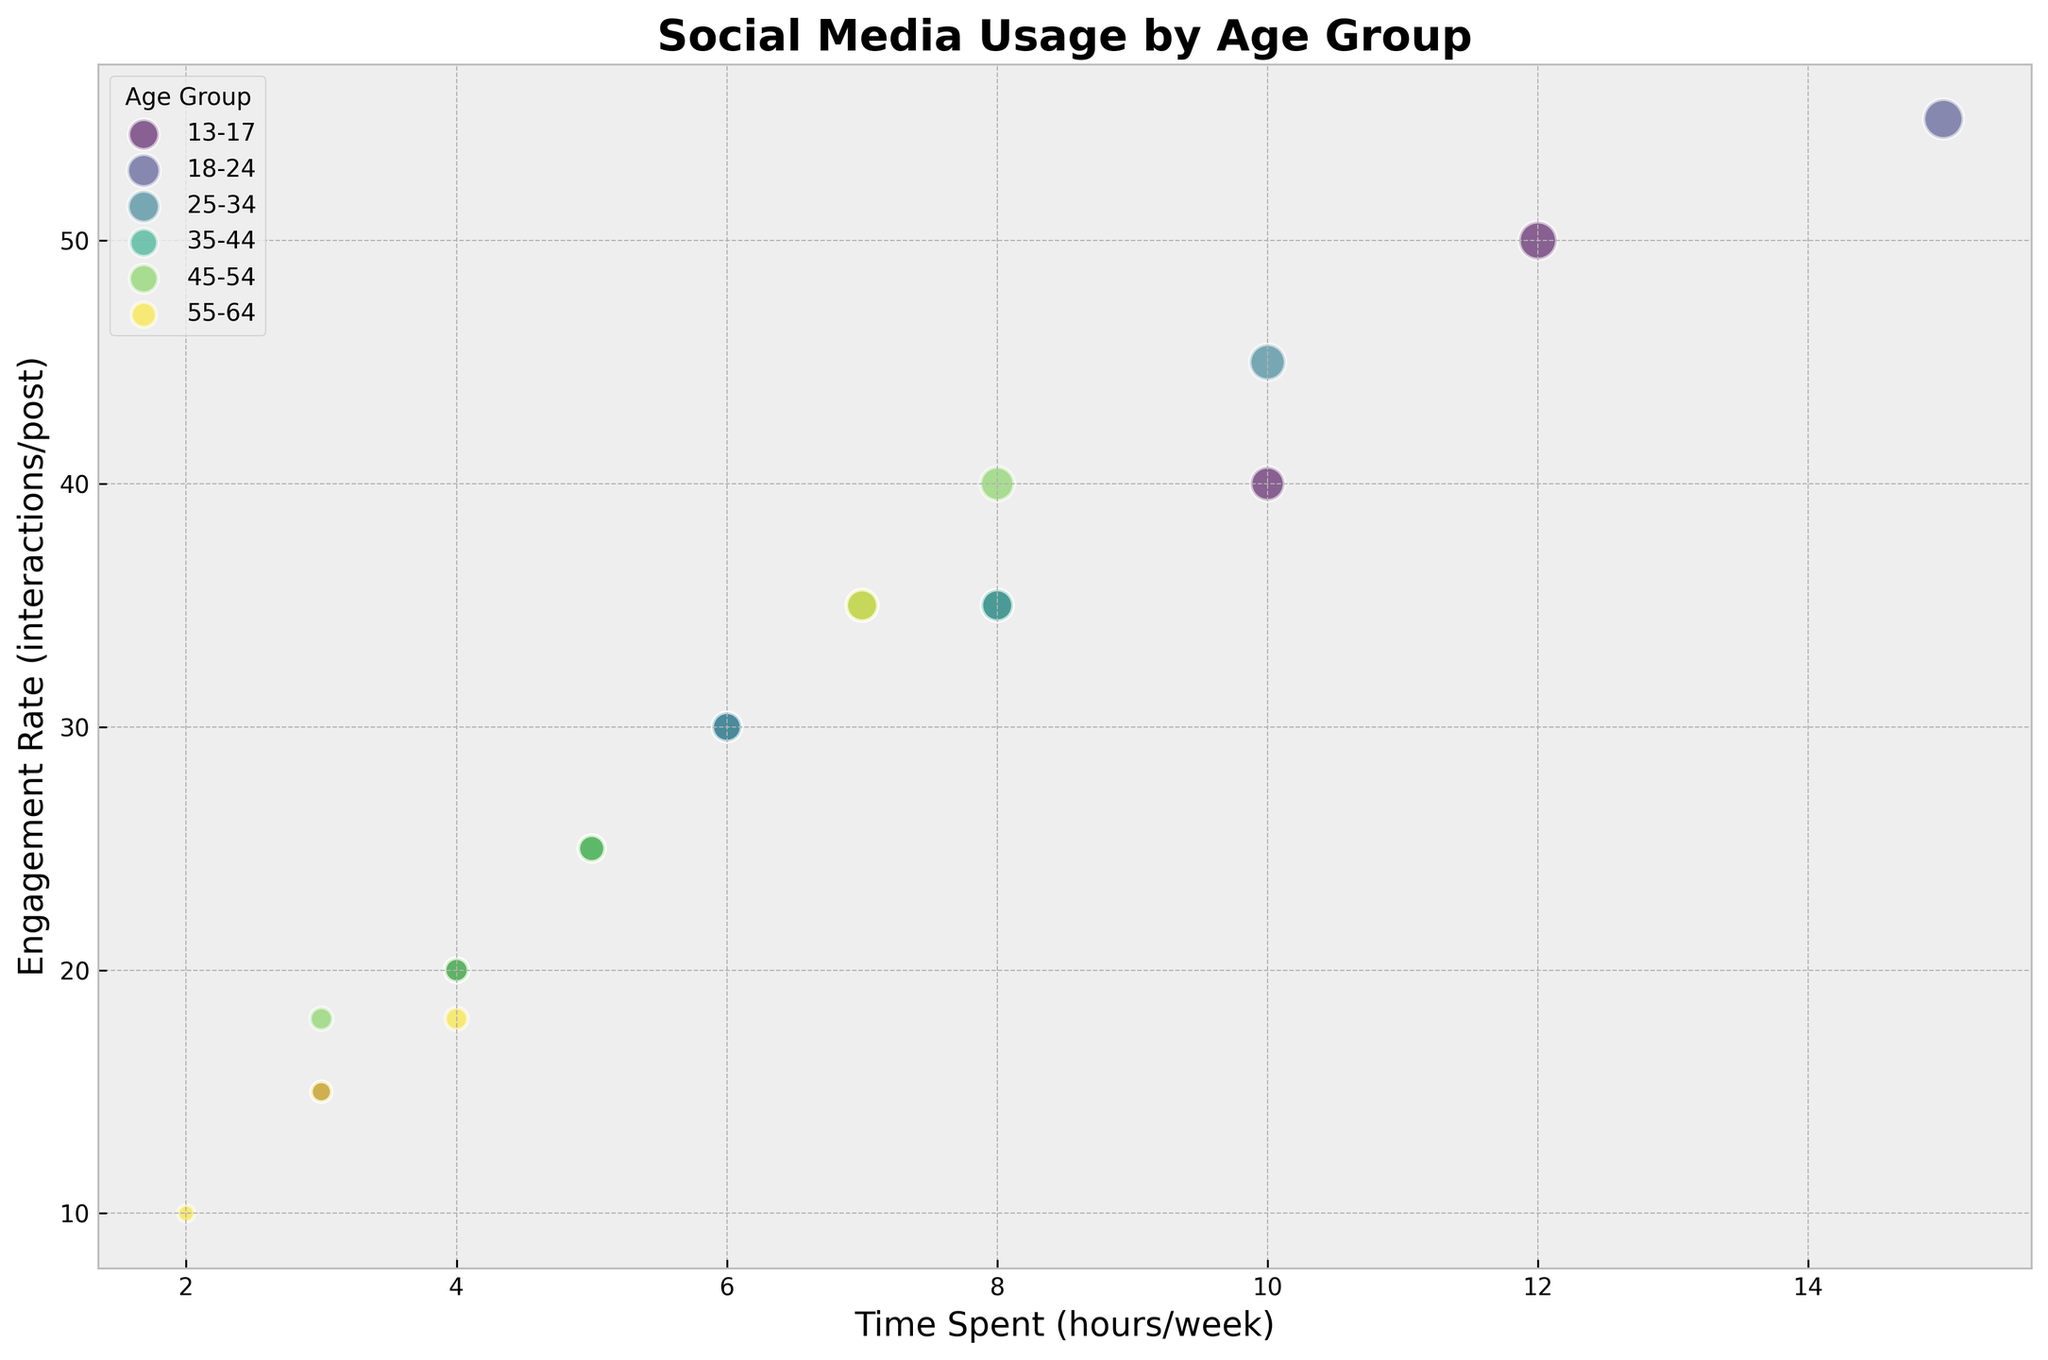What age group spends the most time on TikTok? From the figure, observe all age groups' time spent on TikTok. The highest value is in the 18-24 age group, which spends 15 hours per week on TikTok.
Answer: 18-24 Which platform sees the highest engagement rate for the 35-44 age group? Locate the bubbles for the 35-44 age group and note the engagement rates. TikTok and Facebook have the highest engagement rates, each with 35 interactions per post.
Answer: TikTok and Facebook What is the average amount of time spent on Instagram across all age groups? Identify the time spent on Instagram for each age group: (10 + 8 + 6 + 5 + 4 + 3) = 36 hours. There are six age groups, so the average is 36 / 6 = 6 hours per week.
Answer: 6 hours Which age group has the least engagement on Twitter? Find the engagement rates for Twitter across all age groups: 13-17 (15), 18-24 (20), 25-34 (25), 35-44 (20), 45-54 (18), 55-64 (10). The lowest value is in the 55-64 age group with 10 interactions per post.
Answer: 55-64 Compare the time spent and engagement rate for the 25-34 age group on Facebook. How do they relate? For the 25-34 age group on Facebook, look at the bubble corresponding to Facebook: Time Spent = 6 hours, Engagement Rate = 30 interactions per post.
Answer: Time Spent = 6 hours, Engagement Rate = 30 Which platform has the smallest bubble size for the 13-17 age group? The bubble size is proportional to the engagement rate. For the 13-17 age group, compare Instagram, TikTok, Facebook, and Twitter bubbles. The smallest bubble corresponds to Twitter with an engagement rate of 15.
Answer: Twitter Is there any age group where the average time spent across all platforms is above 10 hours per week? Calculate the average time spent for each age group: 13-17: (10+12+4+3)/4 = 7.25, 18-24: (8+15+5+4)/4 = 8, 25-34: (6+10+6+5)/4 = 6.75, 35-44: (5+7+8+4)/4 = 6, 45-54: (4+5+8+3)/4 = 5, 55-64: (3+4+7+2)/4 = 4. None of the values are above 10.
Answer: No What is the relationship between platform preference and engagement rate for the 18-24 age group? Observe the engagement rates for platforms in the 18-24 age group: Instagram (35), TikTok (55), Facebook (25), and Twitter (20). TikTok has the highest engagement rate, followed by Instagram, Facebook, and Twitter.
Answer: TikTok > Instagram > Facebook > Twitter 